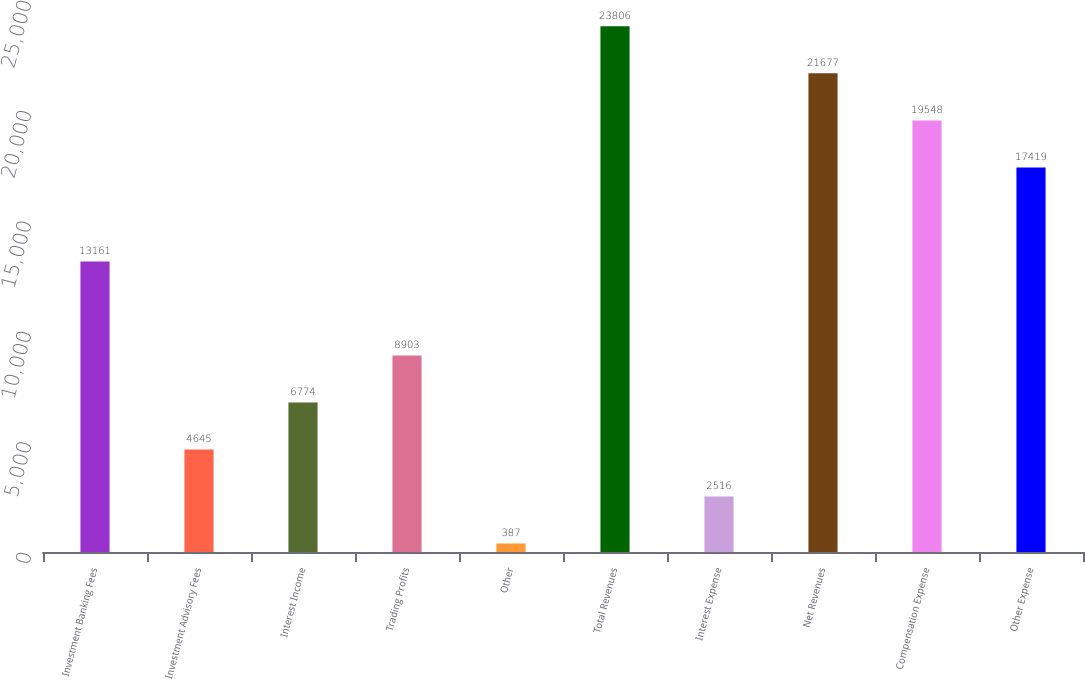Convert chart. <chart><loc_0><loc_0><loc_500><loc_500><bar_chart><fcel>Investment Banking Fees<fcel>Investment Advisory Fees<fcel>Interest Income<fcel>Trading Profits<fcel>Other<fcel>Total Revenues<fcel>Interest Expense<fcel>Net Revenues<fcel>Compensation Expense<fcel>Other Expense<nl><fcel>13161<fcel>4645<fcel>6774<fcel>8903<fcel>387<fcel>23806<fcel>2516<fcel>21677<fcel>19548<fcel>17419<nl></chart> 